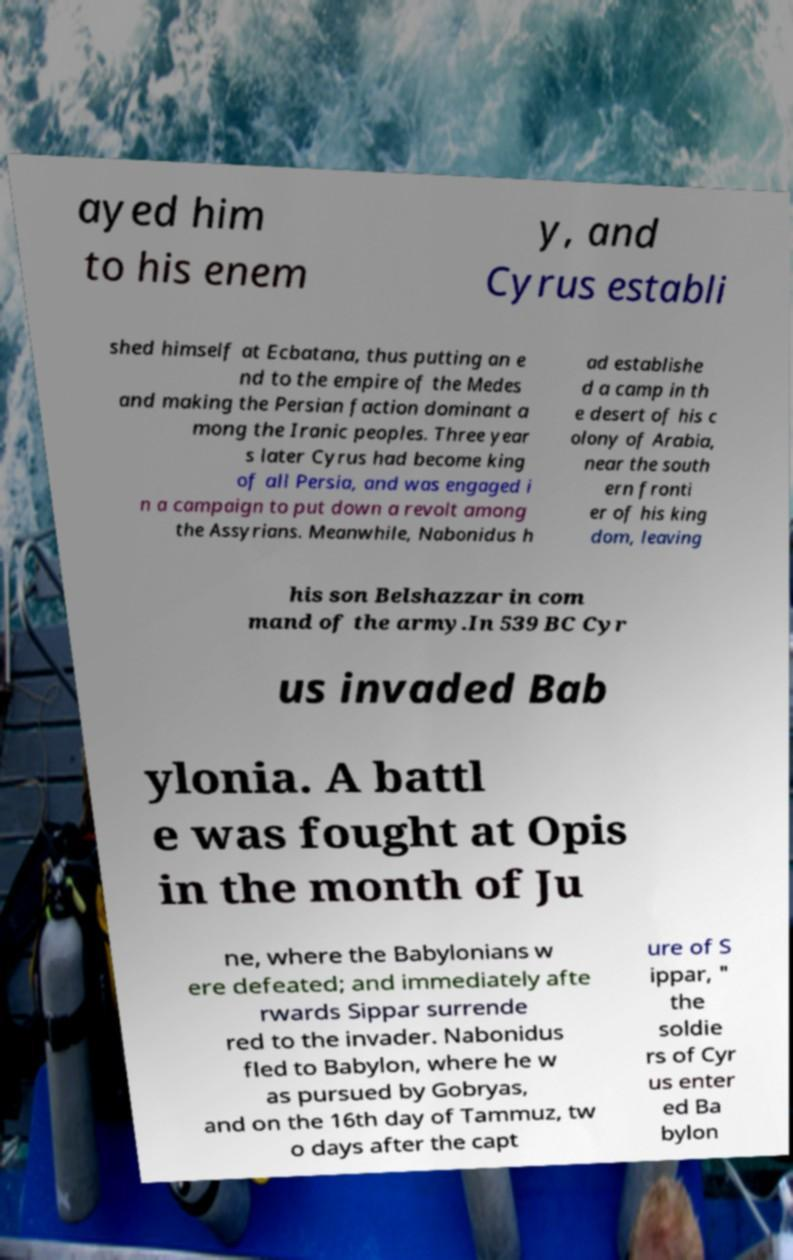Could you assist in decoding the text presented in this image and type it out clearly? ayed him to his enem y, and Cyrus establi shed himself at Ecbatana, thus putting an e nd to the empire of the Medes and making the Persian faction dominant a mong the Iranic peoples. Three year s later Cyrus had become king of all Persia, and was engaged i n a campaign to put down a revolt among the Assyrians. Meanwhile, Nabonidus h ad establishe d a camp in th e desert of his c olony of Arabia, near the south ern fronti er of his king dom, leaving his son Belshazzar in com mand of the army.In 539 BC Cyr us invaded Bab ylonia. A battl e was fought at Opis in the month of Ju ne, where the Babylonians w ere defeated; and immediately afte rwards Sippar surrende red to the invader. Nabonidus fled to Babylon, where he w as pursued by Gobryas, and on the 16th day of Tammuz, tw o days after the capt ure of S ippar, " the soldie rs of Cyr us enter ed Ba bylon 